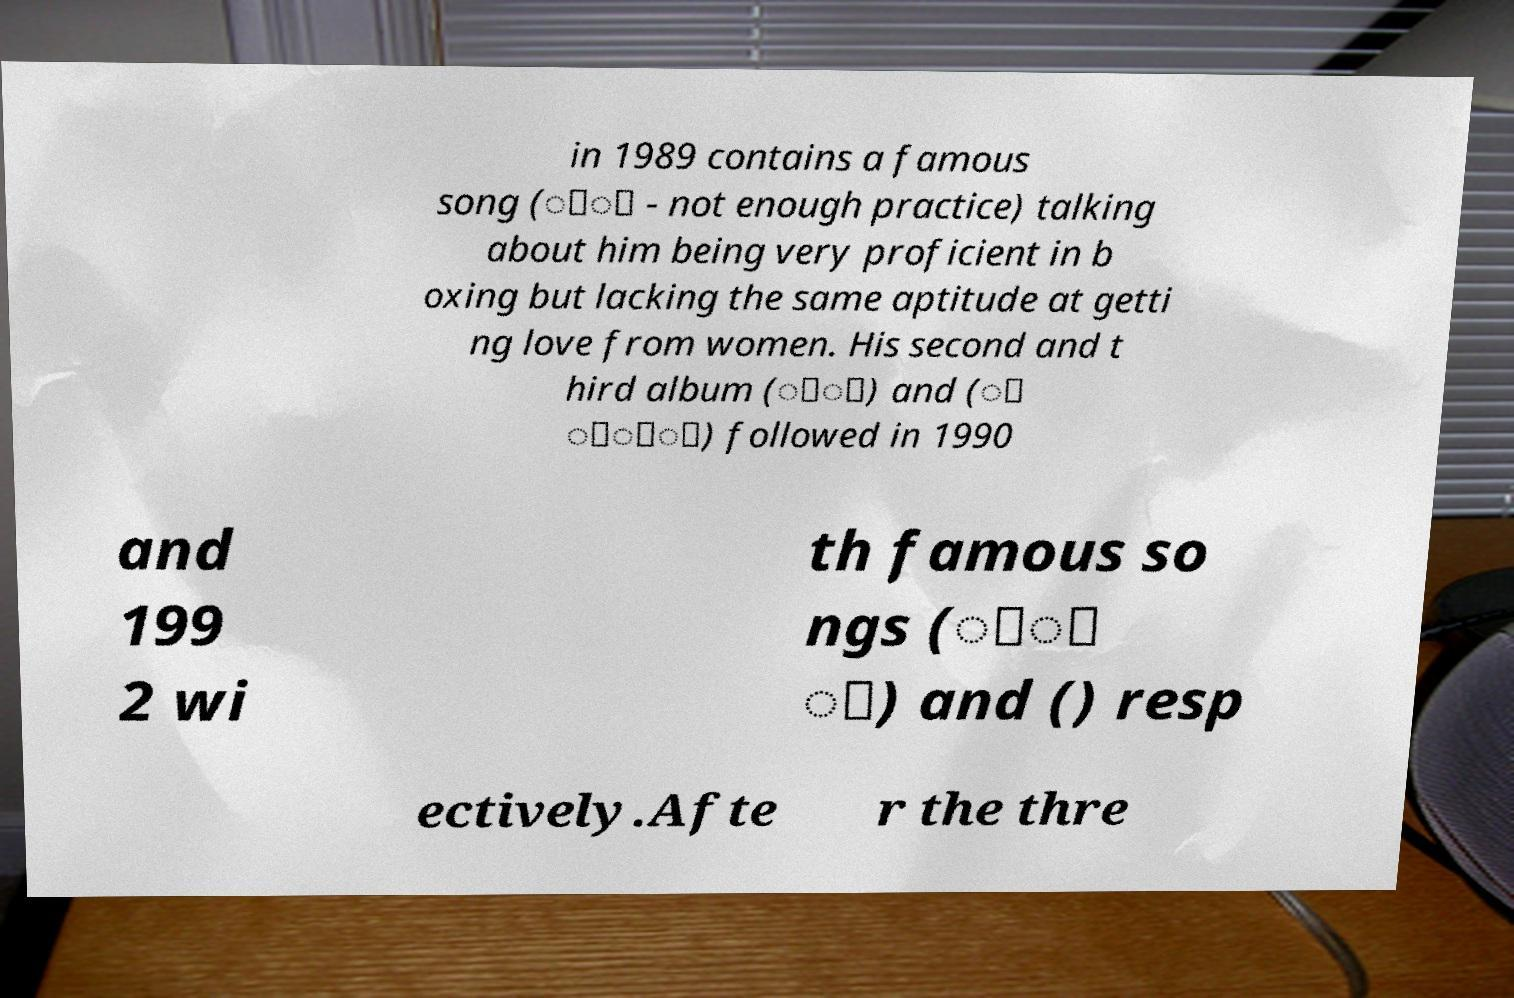For documentation purposes, I need the text within this image transcribed. Could you provide that? in 1989 contains a famous song (่้ - not enough practice) talking about him being very proficient in b oxing but lacking the same aptitude at getti ng love from women. His second and t hird album (์ี) and (ั ้ั์) followed in 1990 and 199 2 wi th famous so ngs (้ิ ู) and () resp ectively.Afte r the thre 